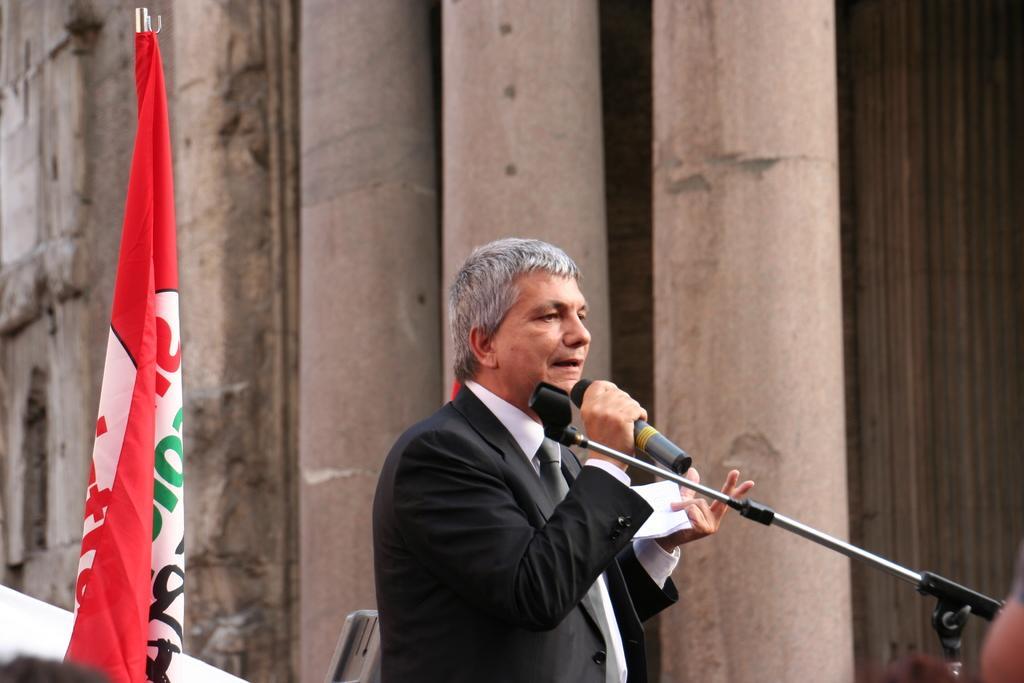In one or two sentences, can you explain what this image depicts? The picture consists of only one person in the middle wearing a black suit and tie and he is holding a microphone and one paper in other hand, behind him there is a flag and beside him there are big pillars and building. 